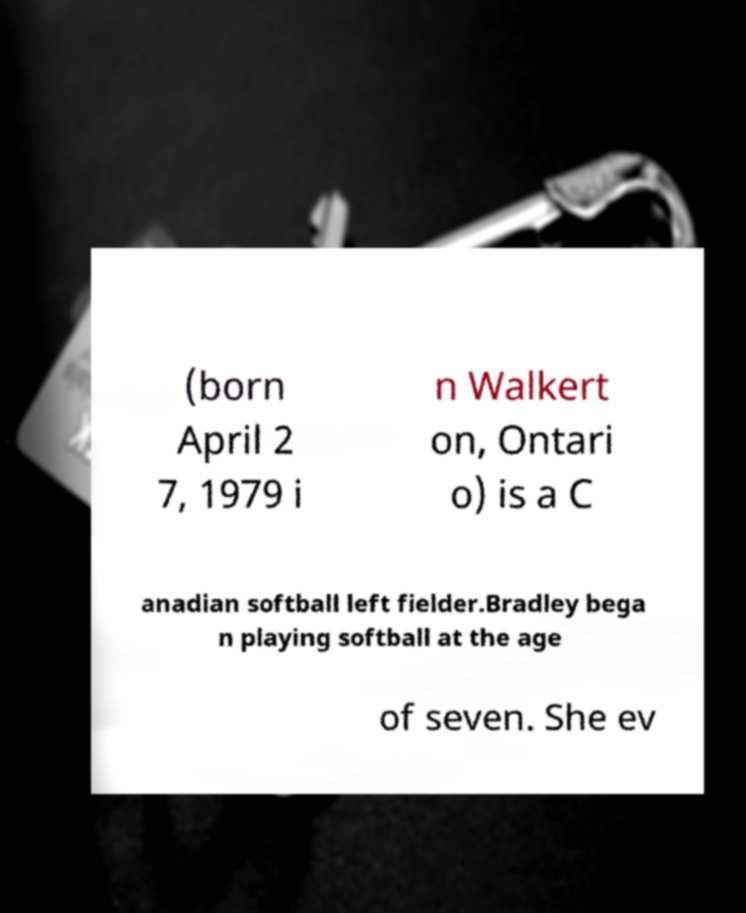Please identify and transcribe the text found in this image. (born April 2 7, 1979 i n Walkert on, Ontari o) is a C anadian softball left fielder.Bradley bega n playing softball at the age of seven. She ev 